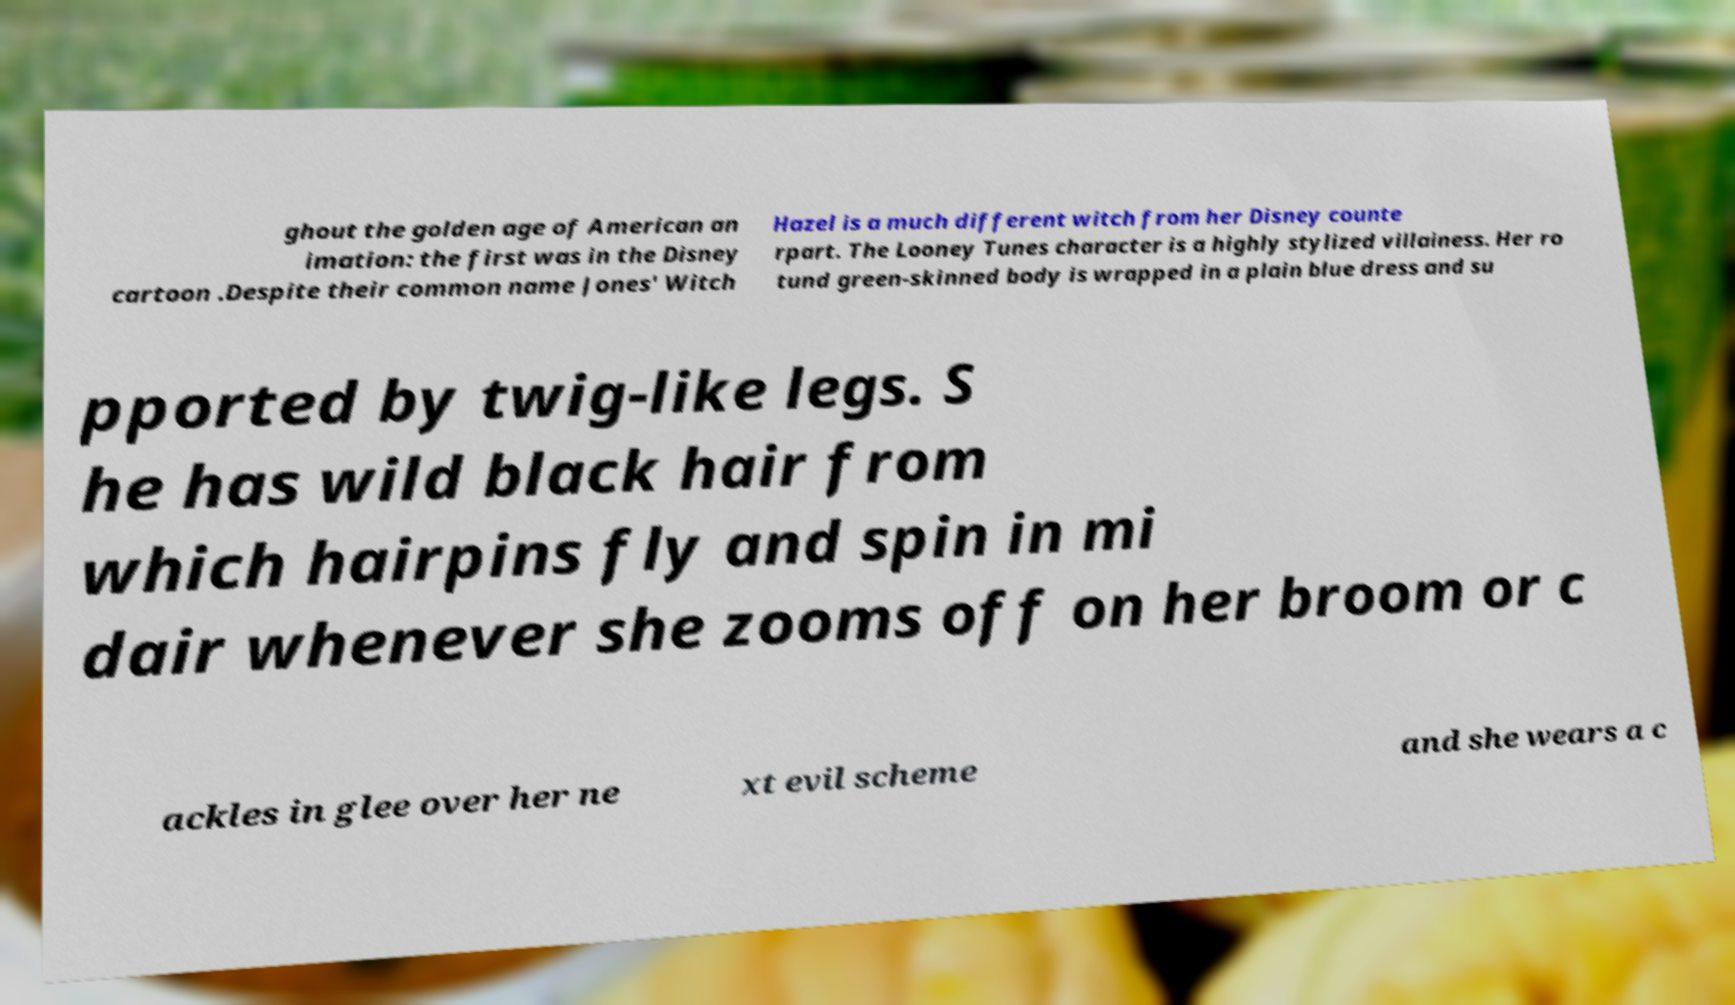What messages or text are displayed in this image? I need them in a readable, typed format. ghout the golden age of American an imation: the first was in the Disney cartoon .Despite their common name Jones' Witch Hazel is a much different witch from her Disney counte rpart. The Looney Tunes character is a highly stylized villainess. Her ro tund green-skinned body is wrapped in a plain blue dress and su pported by twig-like legs. S he has wild black hair from which hairpins fly and spin in mi dair whenever she zooms off on her broom or c ackles in glee over her ne xt evil scheme and she wears a c 